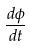<formula> <loc_0><loc_0><loc_500><loc_500>\frac { d \phi } { d t }</formula> 